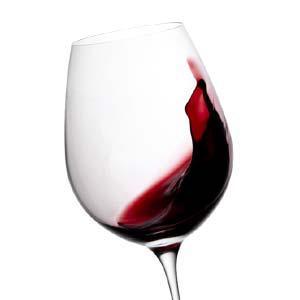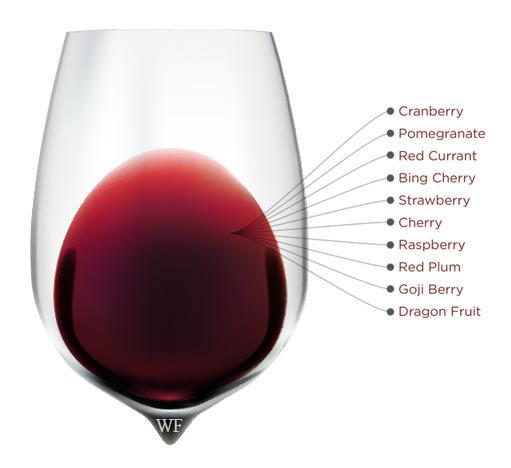The first image is the image on the left, the second image is the image on the right. For the images shown, is this caption "there are exactly two wine glasses in the image on the right." true? Answer yes or no. No. 